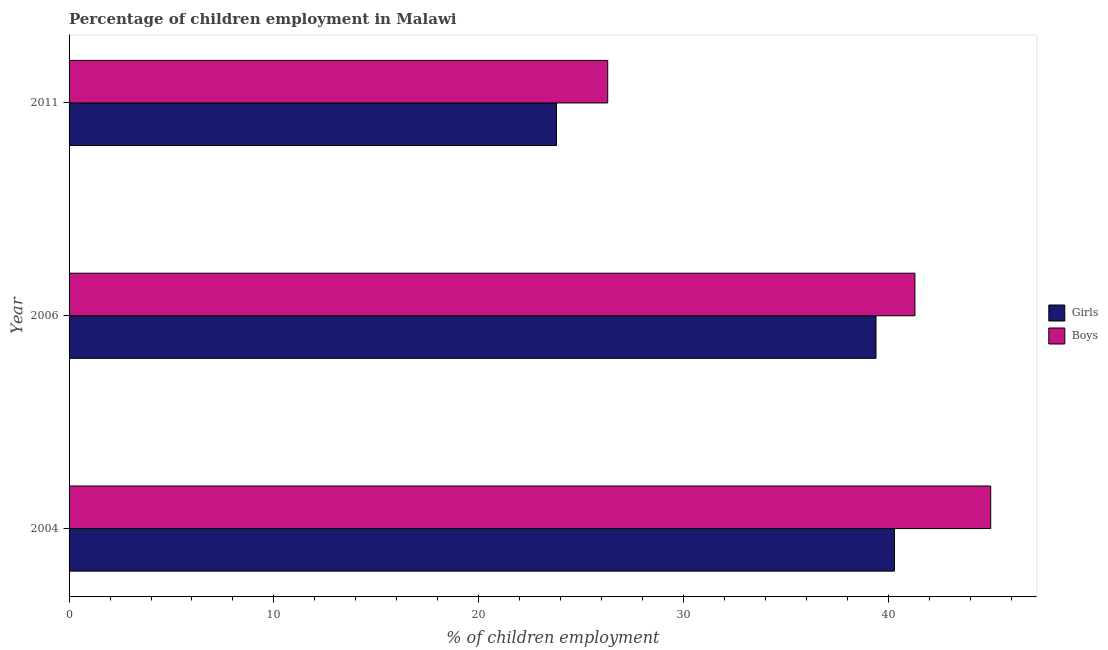How many groups of bars are there?
Your answer should be very brief. 3. Are the number of bars per tick equal to the number of legend labels?
Offer a terse response. Yes. How many bars are there on the 3rd tick from the bottom?
Provide a short and direct response. 2. In how many cases, is the number of bars for a given year not equal to the number of legend labels?
Offer a terse response. 0. What is the percentage of employed boys in 2011?
Offer a very short reply. 26.3. Across all years, what is the minimum percentage of employed girls?
Your answer should be compact. 23.8. In which year was the percentage of employed boys minimum?
Keep it short and to the point. 2011. What is the total percentage of employed boys in the graph?
Keep it short and to the point. 112.6. What is the difference between the percentage of employed girls in 2006 and the percentage of employed boys in 2004?
Ensure brevity in your answer.  -5.6. What is the average percentage of employed boys per year?
Ensure brevity in your answer.  37.53. In the year 2004, what is the difference between the percentage of employed boys and percentage of employed girls?
Provide a short and direct response. 4.7. In how many years, is the percentage of employed boys greater than 22 %?
Offer a terse response. 3. Is the sum of the percentage of employed boys in 2004 and 2011 greater than the maximum percentage of employed girls across all years?
Make the answer very short. Yes. What does the 1st bar from the top in 2006 represents?
Offer a very short reply. Boys. What does the 1st bar from the bottom in 2006 represents?
Your response must be concise. Girls. How many bars are there?
Provide a succinct answer. 6. How many years are there in the graph?
Offer a very short reply. 3. What is the difference between two consecutive major ticks on the X-axis?
Provide a short and direct response. 10. Are the values on the major ticks of X-axis written in scientific E-notation?
Give a very brief answer. No. Does the graph contain any zero values?
Give a very brief answer. No. Does the graph contain grids?
Your answer should be compact. No. Where does the legend appear in the graph?
Keep it short and to the point. Center right. How are the legend labels stacked?
Your response must be concise. Vertical. What is the title of the graph?
Your answer should be compact. Percentage of children employment in Malawi. Does "Goods and services" appear as one of the legend labels in the graph?
Your response must be concise. No. What is the label or title of the X-axis?
Make the answer very short. % of children employment. What is the label or title of the Y-axis?
Give a very brief answer. Year. What is the % of children employment of Girls in 2004?
Keep it short and to the point. 40.3. What is the % of children employment in Girls in 2006?
Your answer should be very brief. 39.4. What is the % of children employment of Boys in 2006?
Provide a short and direct response. 41.3. What is the % of children employment of Girls in 2011?
Offer a terse response. 23.8. What is the % of children employment of Boys in 2011?
Keep it short and to the point. 26.3. Across all years, what is the maximum % of children employment of Girls?
Your response must be concise. 40.3. Across all years, what is the minimum % of children employment in Girls?
Your answer should be compact. 23.8. Across all years, what is the minimum % of children employment of Boys?
Offer a very short reply. 26.3. What is the total % of children employment of Girls in the graph?
Keep it short and to the point. 103.5. What is the total % of children employment of Boys in the graph?
Offer a terse response. 112.6. What is the difference between the % of children employment of Girls in 2004 and that in 2006?
Provide a succinct answer. 0.9. What is the difference between the % of children employment in Girls in 2004 and that in 2011?
Your response must be concise. 16.5. What is the difference between the % of children employment of Boys in 2004 and that in 2011?
Offer a very short reply. 18.7. What is the average % of children employment in Girls per year?
Offer a terse response. 34.5. What is the average % of children employment of Boys per year?
Provide a succinct answer. 37.53. In the year 2004, what is the difference between the % of children employment in Girls and % of children employment in Boys?
Make the answer very short. -4.7. In the year 2006, what is the difference between the % of children employment of Girls and % of children employment of Boys?
Ensure brevity in your answer.  -1.9. In the year 2011, what is the difference between the % of children employment in Girls and % of children employment in Boys?
Provide a succinct answer. -2.5. What is the ratio of the % of children employment in Girls in 2004 to that in 2006?
Your answer should be very brief. 1.02. What is the ratio of the % of children employment in Boys in 2004 to that in 2006?
Offer a terse response. 1.09. What is the ratio of the % of children employment of Girls in 2004 to that in 2011?
Give a very brief answer. 1.69. What is the ratio of the % of children employment in Boys in 2004 to that in 2011?
Your response must be concise. 1.71. What is the ratio of the % of children employment in Girls in 2006 to that in 2011?
Provide a short and direct response. 1.66. What is the ratio of the % of children employment in Boys in 2006 to that in 2011?
Provide a short and direct response. 1.57. What is the difference between the highest and the second highest % of children employment of Girls?
Your response must be concise. 0.9. What is the difference between the highest and the lowest % of children employment in Girls?
Your answer should be very brief. 16.5. What is the difference between the highest and the lowest % of children employment of Boys?
Ensure brevity in your answer.  18.7. 